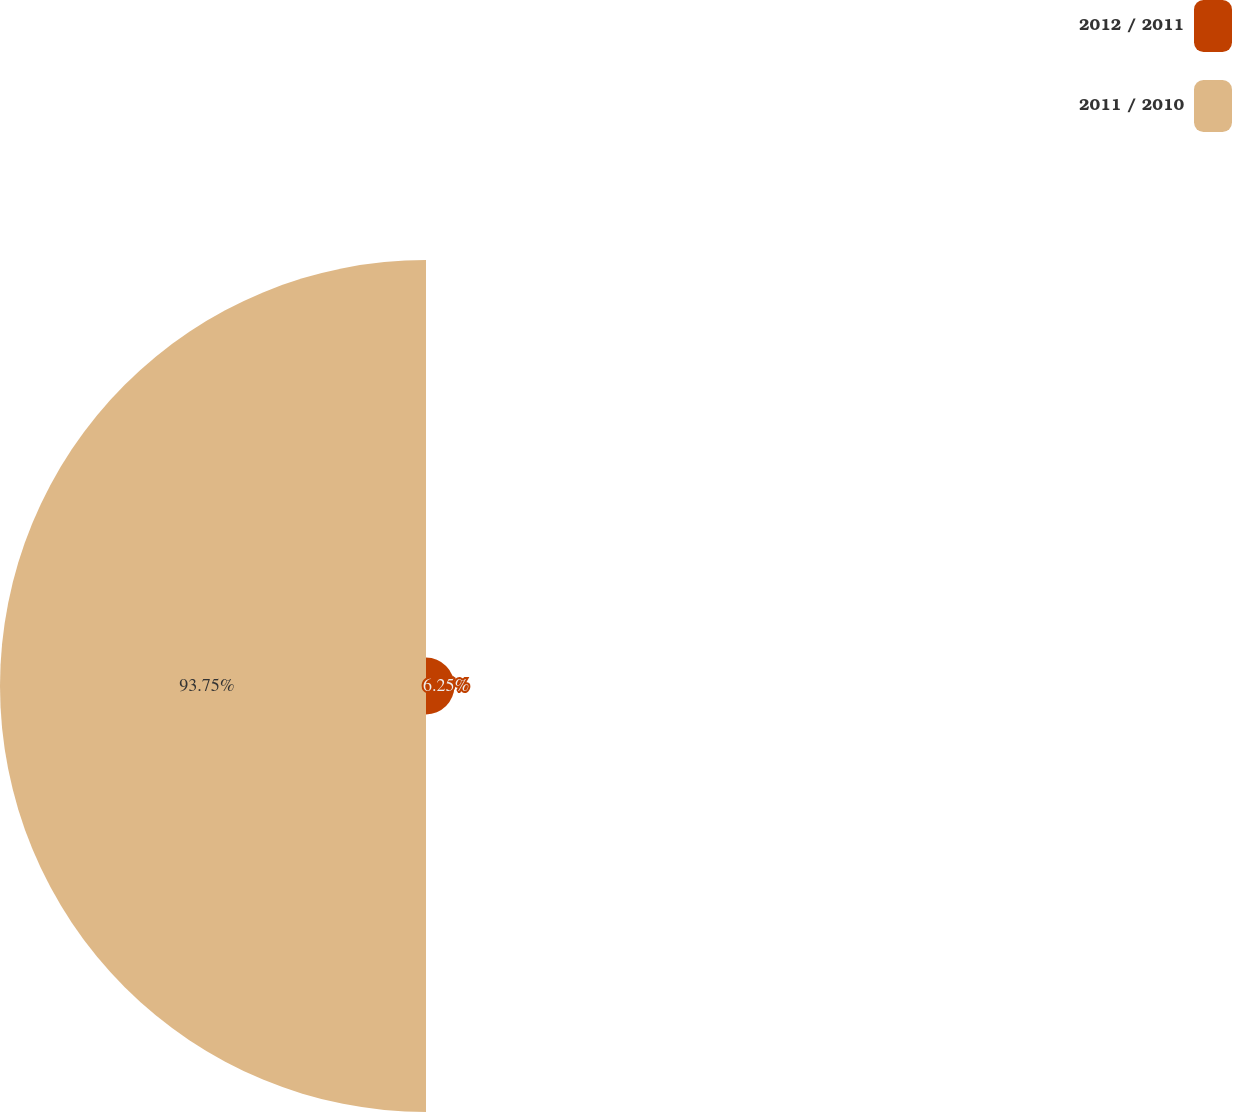<chart> <loc_0><loc_0><loc_500><loc_500><pie_chart><fcel>2012 / 2011<fcel>2011 / 2010<nl><fcel>6.25%<fcel>93.75%<nl></chart> 